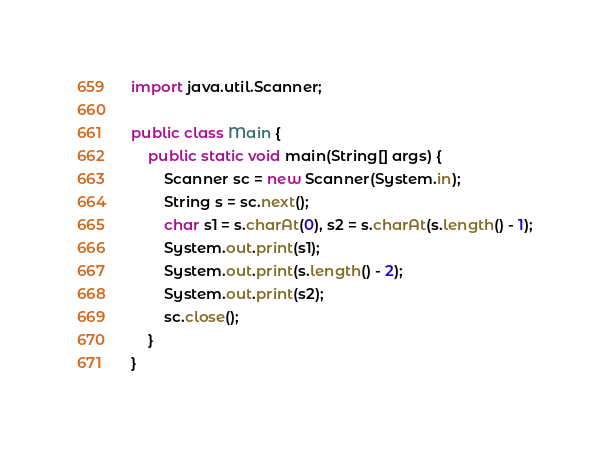Convert code to text. <code><loc_0><loc_0><loc_500><loc_500><_Java_>import java.util.Scanner;

public class Main {
	public static void main(String[] args) {
		Scanner sc = new Scanner(System.in);
		String s = sc.next();
		char s1 = s.charAt(0), s2 = s.charAt(s.length() - 1);
		System.out.print(s1);
		System.out.print(s.length() - 2);
		System.out.print(s2);
		sc.close();
	}
}
</code> 